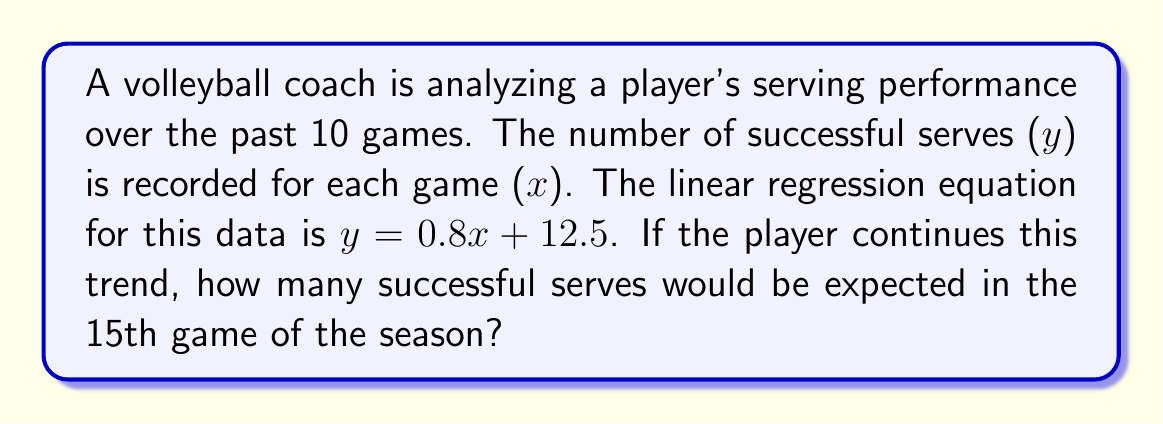Teach me how to tackle this problem. To solve this problem, we'll use the given linear regression equation and follow these steps:

1. Identify the linear regression equation:
   $y = 0.8x + 12.5$

   Where:
   $y$ = number of successful serves
   $x$ = game number

2. We want to find $y$ for the 15th game, so we'll substitute $x = 15$ into the equation:

   $y = 0.8(15) + 12.5$

3. Simplify the right side of the equation:
   $y = 12 + 12.5$

4. Calculate the final result:
   $y = 24.5$

Therefore, if the player continues this performance trend, they would be expected to make 24.5 successful serves in the 15th game.

Since we can't have a fractional number of serves in reality, we would round this to 25 successful serves for a more practical interpretation.
Answer: 24.5 (or 25 rounded) successful serves 